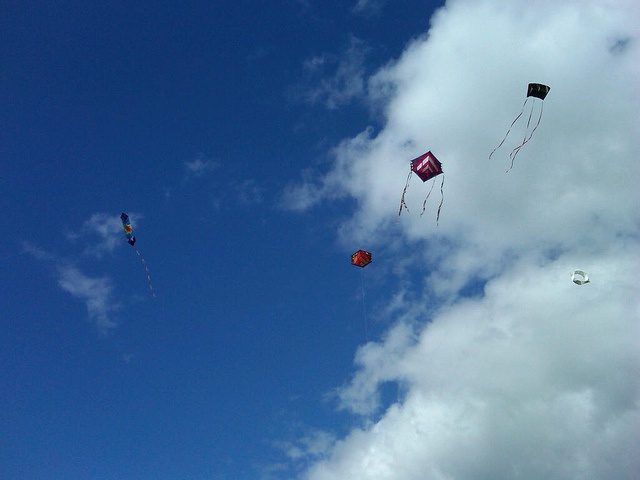Describe the objects in this image and their specific colors. I can see kite in navy, darkgray, lightblue, and black tones, kite in navy, black, maroon, darkgray, and gray tones, kite in navy, blue, and black tones, kite in navy, maroon, black, and brown tones, and kite in navy, lightblue, darkgray, and teal tones in this image. 